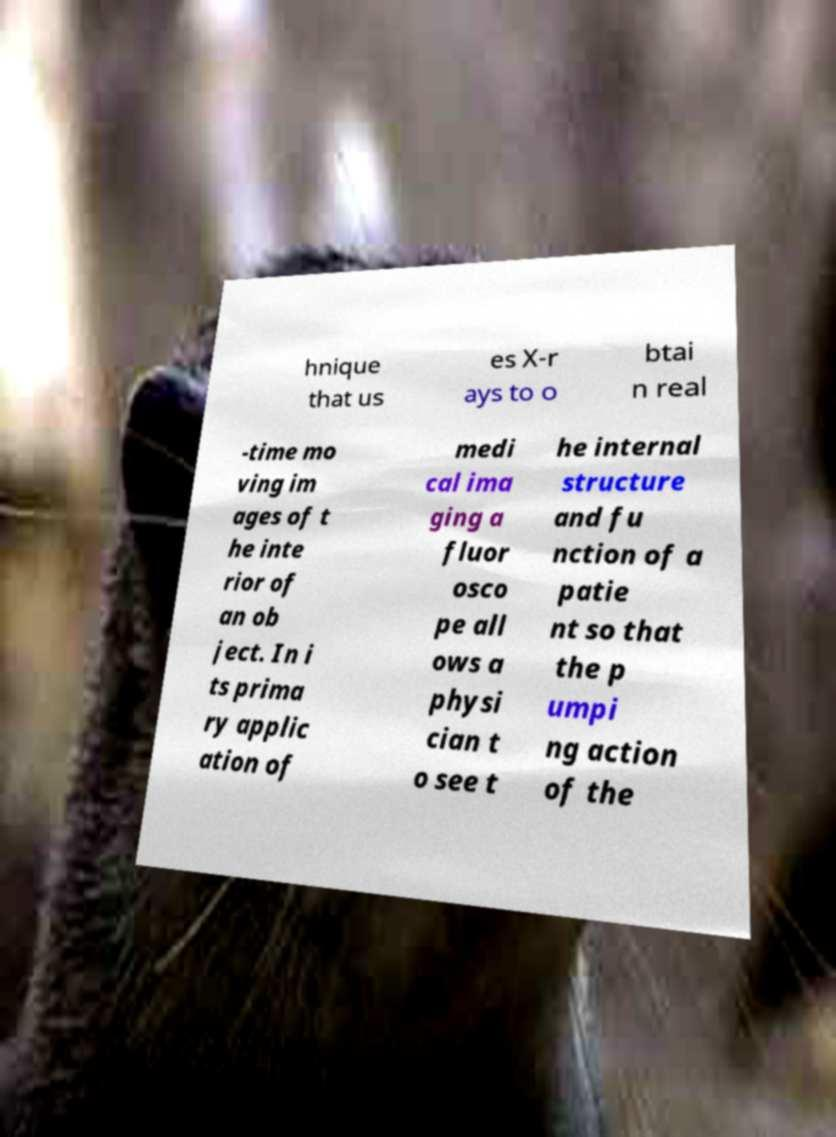Please read and relay the text visible in this image. What does it say? hnique that us es X-r ays to o btai n real -time mo ving im ages of t he inte rior of an ob ject. In i ts prima ry applic ation of medi cal ima ging a fluor osco pe all ows a physi cian t o see t he internal structure and fu nction of a patie nt so that the p umpi ng action of the 